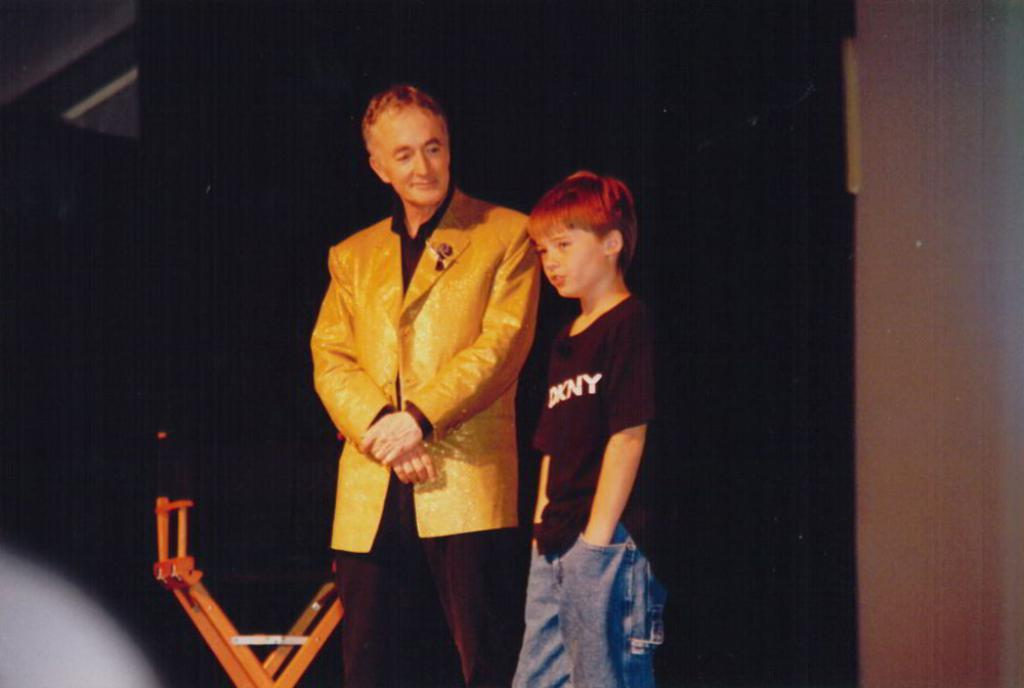How many people are present in the image? There are two people in the image. Can you describe the objects in the background of the image? Unfortunately, the provided facts do not give any information about the objects in the background. What type of feast is being prepared by the two people in the image? There is no indication in the image that a feast is being prepared or that the two people are involved in any food-related activity. 